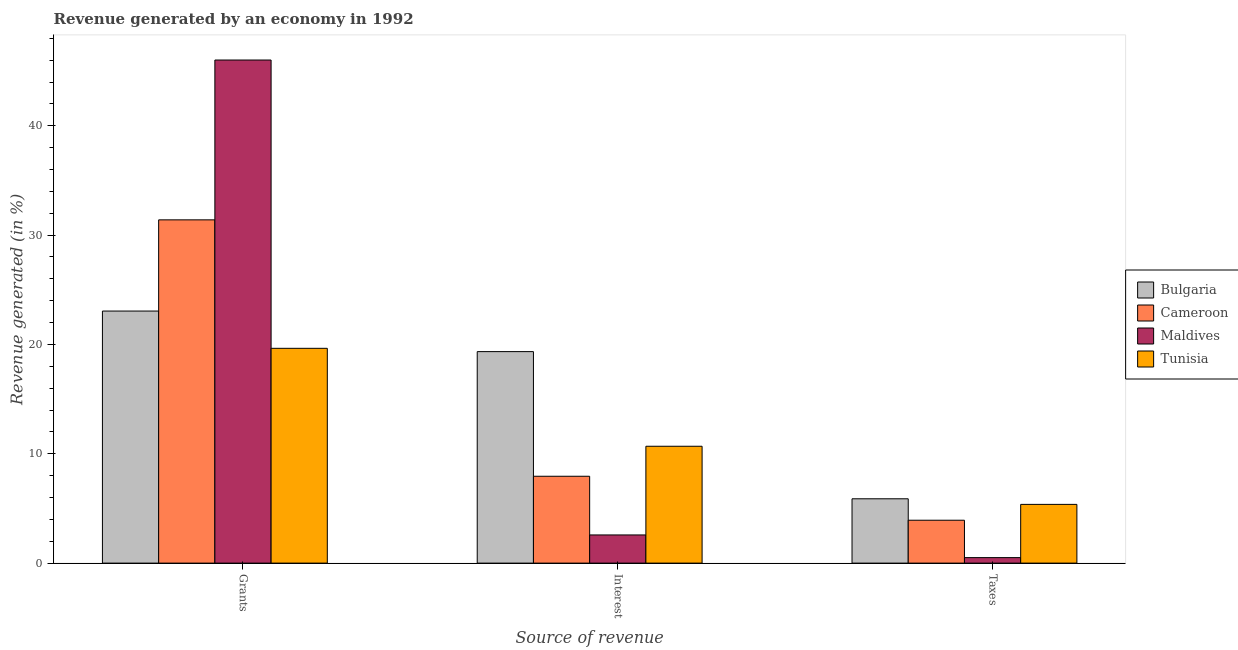Are the number of bars per tick equal to the number of legend labels?
Keep it short and to the point. Yes. Are the number of bars on each tick of the X-axis equal?
Make the answer very short. Yes. How many bars are there on the 2nd tick from the left?
Your response must be concise. 4. How many bars are there on the 1st tick from the right?
Provide a succinct answer. 4. What is the label of the 3rd group of bars from the left?
Make the answer very short. Taxes. What is the percentage of revenue generated by grants in Tunisia?
Offer a very short reply. 19.65. Across all countries, what is the maximum percentage of revenue generated by interest?
Your response must be concise. 19.34. Across all countries, what is the minimum percentage of revenue generated by interest?
Ensure brevity in your answer.  2.58. In which country was the percentage of revenue generated by interest maximum?
Your answer should be compact. Bulgaria. In which country was the percentage of revenue generated by grants minimum?
Give a very brief answer. Tunisia. What is the total percentage of revenue generated by grants in the graph?
Give a very brief answer. 120.11. What is the difference between the percentage of revenue generated by interest in Cameroon and that in Maldives?
Give a very brief answer. 5.37. What is the difference between the percentage of revenue generated by taxes in Bulgaria and the percentage of revenue generated by grants in Cameroon?
Your answer should be very brief. -25.51. What is the average percentage of revenue generated by taxes per country?
Provide a short and direct response. 3.92. What is the difference between the percentage of revenue generated by interest and percentage of revenue generated by grants in Tunisia?
Provide a succinct answer. -8.96. In how many countries, is the percentage of revenue generated by taxes greater than 32 %?
Provide a succinct answer. 0. What is the ratio of the percentage of revenue generated by grants in Maldives to that in Bulgaria?
Your answer should be very brief. 2. Is the percentage of revenue generated by taxes in Tunisia less than that in Bulgaria?
Ensure brevity in your answer.  Yes. Is the difference between the percentage of revenue generated by taxes in Maldives and Bulgaria greater than the difference between the percentage of revenue generated by grants in Maldives and Bulgaria?
Offer a terse response. No. What is the difference between the highest and the second highest percentage of revenue generated by taxes?
Give a very brief answer. 0.51. What is the difference between the highest and the lowest percentage of revenue generated by taxes?
Provide a succinct answer. 5.38. Is the sum of the percentage of revenue generated by grants in Tunisia and Maldives greater than the maximum percentage of revenue generated by taxes across all countries?
Your answer should be compact. Yes. What does the 2nd bar from the left in Grants represents?
Offer a very short reply. Cameroon. What does the 3rd bar from the right in Interest represents?
Your response must be concise. Cameroon. Are all the bars in the graph horizontal?
Keep it short and to the point. No. How many countries are there in the graph?
Make the answer very short. 4. What is the difference between two consecutive major ticks on the Y-axis?
Give a very brief answer. 10. Does the graph contain any zero values?
Provide a succinct answer. No. Where does the legend appear in the graph?
Offer a terse response. Center right. How are the legend labels stacked?
Offer a terse response. Vertical. What is the title of the graph?
Keep it short and to the point. Revenue generated by an economy in 1992. What is the label or title of the X-axis?
Give a very brief answer. Source of revenue. What is the label or title of the Y-axis?
Your response must be concise. Revenue generated (in %). What is the Revenue generated (in %) of Bulgaria in Grants?
Offer a terse response. 23.05. What is the Revenue generated (in %) in Cameroon in Grants?
Your answer should be compact. 31.4. What is the Revenue generated (in %) of Maldives in Grants?
Your response must be concise. 46.01. What is the Revenue generated (in %) of Tunisia in Grants?
Your answer should be very brief. 19.65. What is the Revenue generated (in %) of Bulgaria in Interest?
Give a very brief answer. 19.34. What is the Revenue generated (in %) in Cameroon in Interest?
Your answer should be compact. 7.94. What is the Revenue generated (in %) in Maldives in Interest?
Your answer should be compact. 2.58. What is the Revenue generated (in %) in Tunisia in Interest?
Keep it short and to the point. 10.69. What is the Revenue generated (in %) in Bulgaria in Taxes?
Your response must be concise. 5.88. What is the Revenue generated (in %) in Cameroon in Taxes?
Your answer should be compact. 3.92. What is the Revenue generated (in %) of Maldives in Taxes?
Make the answer very short. 0.5. What is the Revenue generated (in %) in Tunisia in Taxes?
Offer a very short reply. 5.37. Across all Source of revenue, what is the maximum Revenue generated (in %) in Bulgaria?
Offer a very short reply. 23.05. Across all Source of revenue, what is the maximum Revenue generated (in %) in Cameroon?
Provide a succinct answer. 31.4. Across all Source of revenue, what is the maximum Revenue generated (in %) in Maldives?
Keep it short and to the point. 46.01. Across all Source of revenue, what is the maximum Revenue generated (in %) in Tunisia?
Your answer should be very brief. 19.65. Across all Source of revenue, what is the minimum Revenue generated (in %) in Bulgaria?
Your answer should be compact. 5.88. Across all Source of revenue, what is the minimum Revenue generated (in %) of Cameroon?
Keep it short and to the point. 3.92. Across all Source of revenue, what is the minimum Revenue generated (in %) in Maldives?
Provide a succinct answer. 0.5. Across all Source of revenue, what is the minimum Revenue generated (in %) of Tunisia?
Offer a very short reply. 5.37. What is the total Revenue generated (in %) in Bulgaria in the graph?
Ensure brevity in your answer.  48.28. What is the total Revenue generated (in %) in Cameroon in the graph?
Make the answer very short. 43.26. What is the total Revenue generated (in %) in Maldives in the graph?
Provide a succinct answer. 49.09. What is the total Revenue generated (in %) in Tunisia in the graph?
Ensure brevity in your answer.  35.71. What is the difference between the Revenue generated (in %) of Bulgaria in Grants and that in Interest?
Ensure brevity in your answer.  3.71. What is the difference between the Revenue generated (in %) in Cameroon in Grants and that in Interest?
Provide a succinct answer. 23.45. What is the difference between the Revenue generated (in %) of Maldives in Grants and that in Interest?
Give a very brief answer. 43.44. What is the difference between the Revenue generated (in %) of Tunisia in Grants and that in Interest?
Keep it short and to the point. 8.96. What is the difference between the Revenue generated (in %) of Bulgaria in Grants and that in Taxes?
Offer a terse response. 17.17. What is the difference between the Revenue generated (in %) of Cameroon in Grants and that in Taxes?
Your answer should be very brief. 27.47. What is the difference between the Revenue generated (in %) of Maldives in Grants and that in Taxes?
Your answer should be very brief. 45.51. What is the difference between the Revenue generated (in %) in Tunisia in Grants and that in Taxes?
Keep it short and to the point. 14.27. What is the difference between the Revenue generated (in %) of Bulgaria in Interest and that in Taxes?
Give a very brief answer. 13.46. What is the difference between the Revenue generated (in %) of Cameroon in Interest and that in Taxes?
Keep it short and to the point. 4.02. What is the difference between the Revenue generated (in %) of Maldives in Interest and that in Taxes?
Keep it short and to the point. 2.07. What is the difference between the Revenue generated (in %) in Tunisia in Interest and that in Taxes?
Your answer should be compact. 5.32. What is the difference between the Revenue generated (in %) of Bulgaria in Grants and the Revenue generated (in %) of Cameroon in Interest?
Make the answer very short. 15.11. What is the difference between the Revenue generated (in %) of Bulgaria in Grants and the Revenue generated (in %) of Maldives in Interest?
Provide a short and direct response. 20.48. What is the difference between the Revenue generated (in %) in Bulgaria in Grants and the Revenue generated (in %) in Tunisia in Interest?
Provide a succinct answer. 12.37. What is the difference between the Revenue generated (in %) of Cameroon in Grants and the Revenue generated (in %) of Maldives in Interest?
Make the answer very short. 28.82. What is the difference between the Revenue generated (in %) in Cameroon in Grants and the Revenue generated (in %) in Tunisia in Interest?
Your response must be concise. 20.71. What is the difference between the Revenue generated (in %) in Maldives in Grants and the Revenue generated (in %) in Tunisia in Interest?
Your answer should be compact. 35.33. What is the difference between the Revenue generated (in %) in Bulgaria in Grants and the Revenue generated (in %) in Cameroon in Taxes?
Provide a succinct answer. 19.13. What is the difference between the Revenue generated (in %) in Bulgaria in Grants and the Revenue generated (in %) in Maldives in Taxes?
Offer a terse response. 22.55. What is the difference between the Revenue generated (in %) of Bulgaria in Grants and the Revenue generated (in %) of Tunisia in Taxes?
Offer a terse response. 17.68. What is the difference between the Revenue generated (in %) of Cameroon in Grants and the Revenue generated (in %) of Maldives in Taxes?
Keep it short and to the point. 30.89. What is the difference between the Revenue generated (in %) of Cameroon in Grants and the Revenue generated (in %) of Tunisia in Taxes?
Make the answer very short. 26.02. What is the difference between the Revenue generated (in %) of Maldives in Grants and the Revenue generated (in %) of Tunisia in Taxes?
Offer a terse response. 40.64. What is the difference between the Revenue generated (in %) in Bulgaria in Interest and the Revenue generated (in %) in Cameroon in Taxes?
Make the answer very short. 15.42. What is the difference between the Revenue generated (in %) in Bulgaria in Interest and the Revenue generated (in %) in Maldives in Taxes?
Keep it short and to the point. 18.84. What is the difference between the Revenue generated (in %) of Bulgaria in Interest and the Revenue generated (in %) of Tunisia in Taxes?
Your response must be concise. 13.97. What is the difference between the Revenue generated (in %) of Cameroon in Interest and the Revenue generated (in %) of Maldives in Taxes?
Provide a succinct answer. 7.44. What is the difference between the Revenue generated (in %) in Cameroon in Interest and the Revenue generated (in %) in Tunisia in Taxes?
Ensure brevity in your answer.  2.57. What is the difference between the Revenue generated (in %) in Maldives in Interest and the Revenue generated (in %) in Tunisia in Taxes?
Offer a very short reply. -2.8. What is the average Revenue generated (in %) of Bulgaria per Source of revenue?
Give a very brief answer. 16.09. What is the average Revenue generated (in %) in Cameroon per Source of revenue?
Your answer should be very brief. 14.42. What is the average Revenue generated (in %) in Maldives per Source of revenue?
Your answer should be compact. 16.36. What is the average Revenue generated (in %) in Tunisia per Source of revenue?
Provide a short and direct response. 11.9. What is the difference between the Revenue generated (in %) of Bulgaria and Revenue generated (in %) of Cameroon in Grants?
Your answer should be compact. -8.34. What is the difference between the Revenue generated (in %) of Bulgaria and Revenue generated (in %) of Maldives in Grants?
Your answer should be very brief. -22.96. What is the difference between the Revenue generated (in %) in Bulgaria and Revenue generated (in %) in Tunisia in Grants?
Provide a short and direct response. 3.41. What is the difference between the Revenue generated (in %) in Cameroon and Revenue generated (in %) in Maldives in Grants?
Your answer should be compact. -14.62. What is the difference between the Revenue generated (in %) of Cameroon and Revenue generated (in %) of Tunisia in Grants?
Provide a short and direct response. 11.75. What is the difference between the Revenue generated (in %) of Maldives and Revenue generated (in %) of Tunisia in Grants?
Your answer should be very brief. 26.37. What is the difference between the Revenue generated (in %) of Bulgaria and Revenue generated (in %) of Cameroon in Interest?
Your answer should be very brief. 11.4. What is the difference between the Revenue generated (in %) of Bulgaria and Revenue generated (in %) of Maldives in Interest?
Make the answer very short. 16.77. What is the difference between the Revenue generated (in %) of Bulgaria and Revenue generated (in %) of Tunisia in Interest?
Give a very brief answer. 8.66. What is the difference between the Revenue generated (in %) in Cameroon and Revenue generated (in %) in Maldives in Interest?
Provide a succinct answer. 5.37. What is the difference between the Revenue generated (in %) of Cameroon and Revenue generated (in %) of Tunisia in Interest?
Your answer should be compact. -2.74. What is the difference between the Revenue generated (in %) of Maldives and Revenue generated (in %) of Tunisia in Interest?
Offer a very short reply. -8.11. What is the difference between the Revenue generated (in %) of Bulgaria and Revenue generated (in %) of Cameroon in Taxes?
Provide a succinct answer. 1.96. What is the difference between the Revenue generated (in %) of Bulgaria and Revenue generated (in %) of Maldives in Taxes?
Your answer should be compact. 5.38. What is the difference between the Revenue generated (in %) in Bulgaria and Revenue generated (in %) in Tunisia in Taxes?
Your response must be concise. 0.51. What is the difference between the Revenue generated (in %) of Cameroon and Revenue generated (in %) of Maldives in Taxes?
Offer a very short reply. 3.42. What is the difference between the Revenue generated (in %) of Cameroon and Revenue generated (in %) of Tunisia in Taxes?
Provide a succinct answer. -1.45. What is the difference between the Revenue generated (in %) in Maldives and Revenue generated (in %) in Tunisia in Taxes?
Your answer should be very brief. -4.87. What is the ratio of the Revenue generated (in %) in Bulgaria in Grants to that in Interest?
Provide a short and direct response. 1.19. What is the ratio of the Revenue generated (in %) of Cameroon in Grants to that in Interest?
Give a very brief answer. 3.95. What is the ratio of the Revenue generated (in %) of Maldives in Grants to that in Interest?
Provide a short and direct response. 17.86. What is the ratio of the Revenue generated (in %) of Tunisia in Grants to that in Interest?
Offer a very short reply. 1.84. What is the ratio of the Revenue generated (in %) of Bulgaria in Grants to that in Taxes?
Keep it short and to the point. 3.92. What is the ratio of the Revenue generated (in %) in Cameroon in Grants to that in Taxes?
Provide a short and direct response. 8.01. What is the ratio of the Revenue generated (in %) of Maldives in Grants to that in Taxes?
Offer a very short reply. 91.4. What is the ratio of the Revenue generated (in %) in Tunisia in Grants to that in Taxes?
Your answer should be very brief. 3.66. What is the ratio of the Revenue generated (in %) in Bulgaria in Interest to that in Taxes?
Offer a terse response. 3.29. What is the ratio of the Revenue generated (in %) in Cameroon in Interest to that in Taxes?
Offer a very short reply. 2.03. What is the ratio of the Revenue generated (in %) in Maldives in Interest to that in Taxes?
Provide a short and direct response. 5.12. What is the ratio of the Revenue generated (in %) in Tunisia in Interest to that in Taxes?
Ensure brevity in your answer.  1.99. What is the difference between the highest and the second highest Revenue generated (in %) in Bulgaria?
Your response must be concise. 3.71. What is the difference between the highest and the second highest Revenue generated (in %) of Cameroon?
Offer a very short reply. 23.45. What is the difference between the highest and the second highest Revenue generated (in %) of Maldives?
Ensure brevity in your answer.  43.44. What is the difference between the highest and the second highest Revenue generated (in %) of Tunisia?
Provide a short and direct response. 8.96. What is the difference between the highest and the lowest Revenue generated (in %) in Bulgaria?
Your answer should be very brief. 17.17. What is the difference between the highest and the lowest Revenue generated (in %) in Cameroon?
Give a very brief answer. 27.47. What is the difference between the highest and the lowest Revenue generated (in %) in Maldives?
Give a very brief answer. 45.51. What is the difference between the highest and the lowest Revenue generated (in %) of Tunisia?
Give a very brief answer. 14.27. 